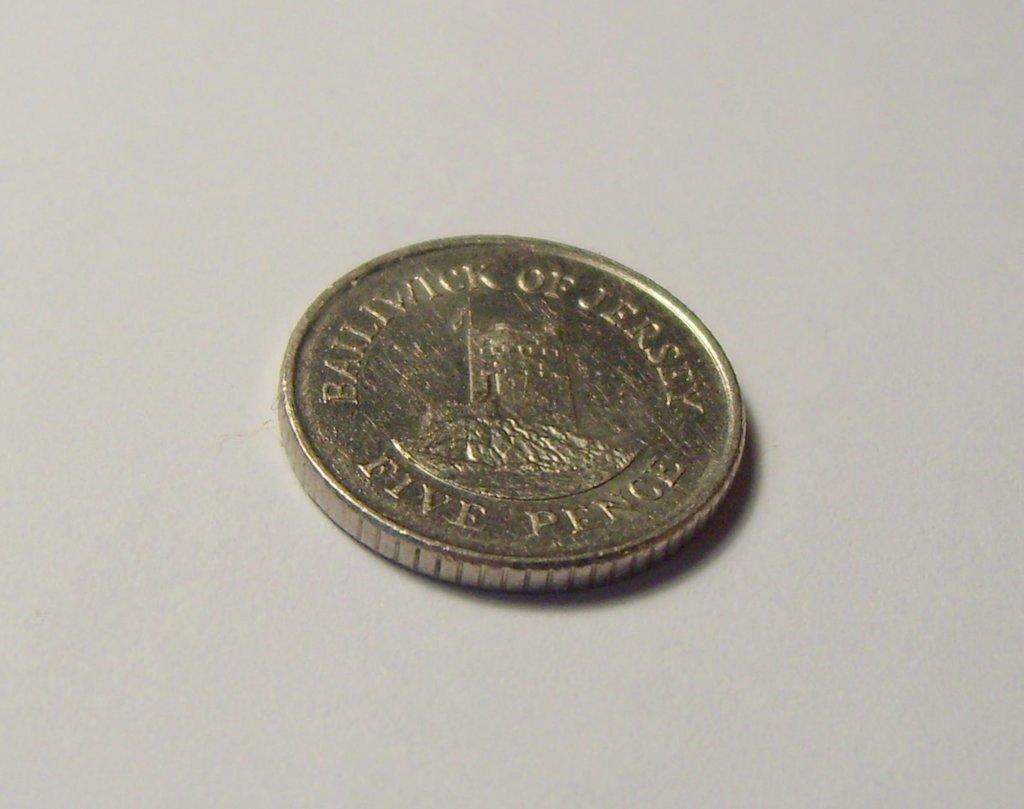<image>
Provide a brief description of the given image. A round coin on a table that says Balltwtck of Jersey. 